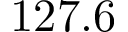<formula> <loc_0><loc_0><loc_500><loc_500>1 2 7 . 6</formula> 